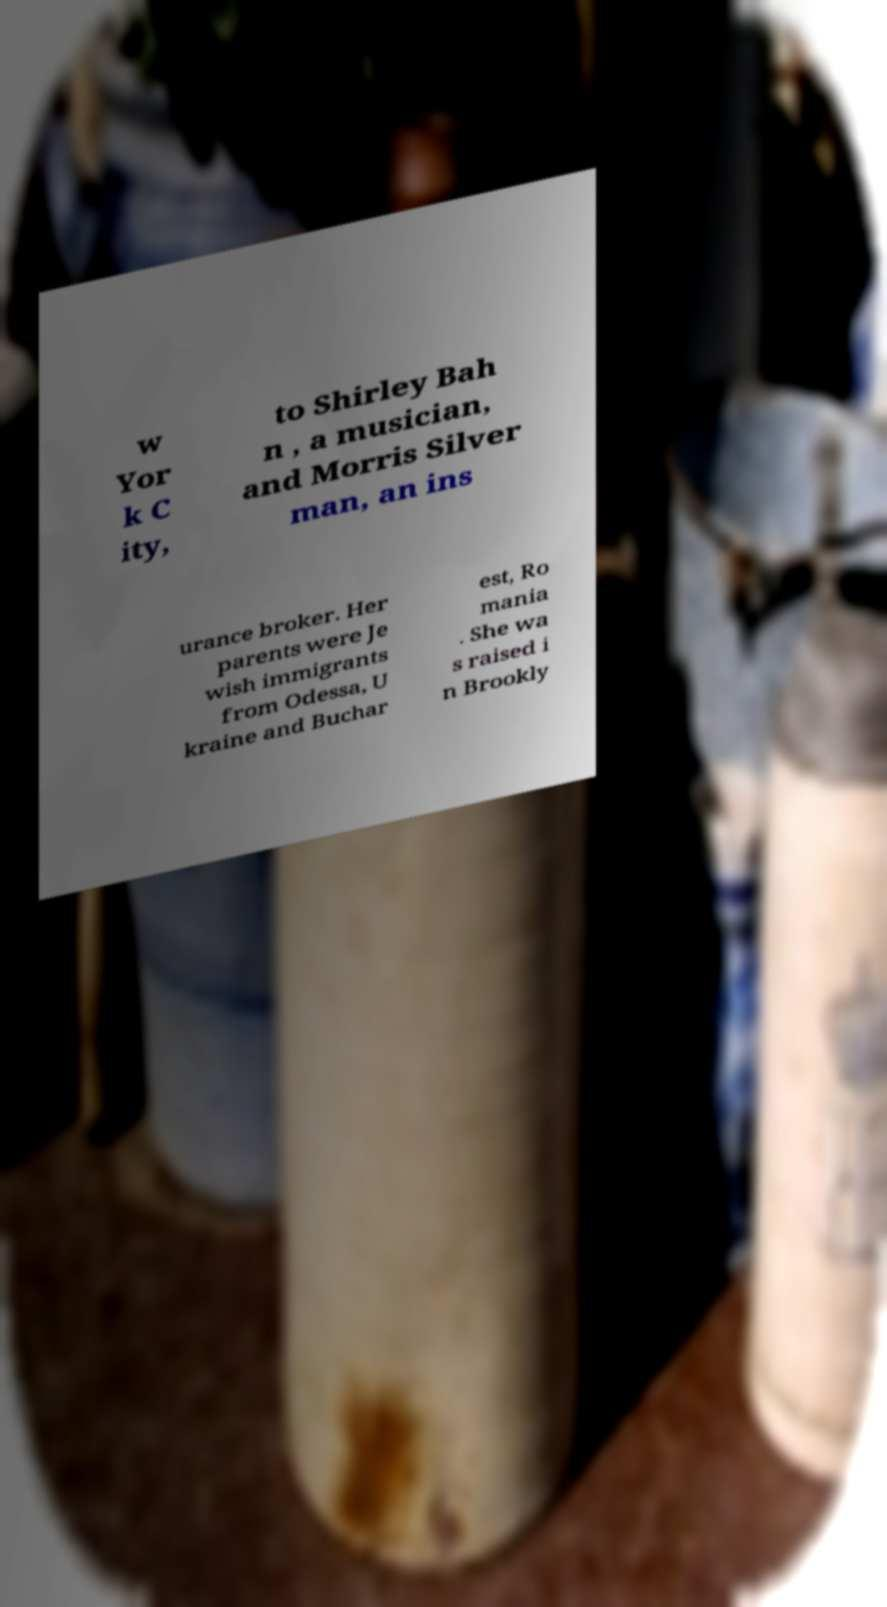Could you assist in decoding the text presented in this image and type it out clearly? w Yor k C ity, to Shirley Bah n , a musician, and Morris Silver man, an ins urance broker. Her parents were Je wish immigrants from Odessa, U kraine and Buchar est, Ro mania . She wa s raised i n Brookly 